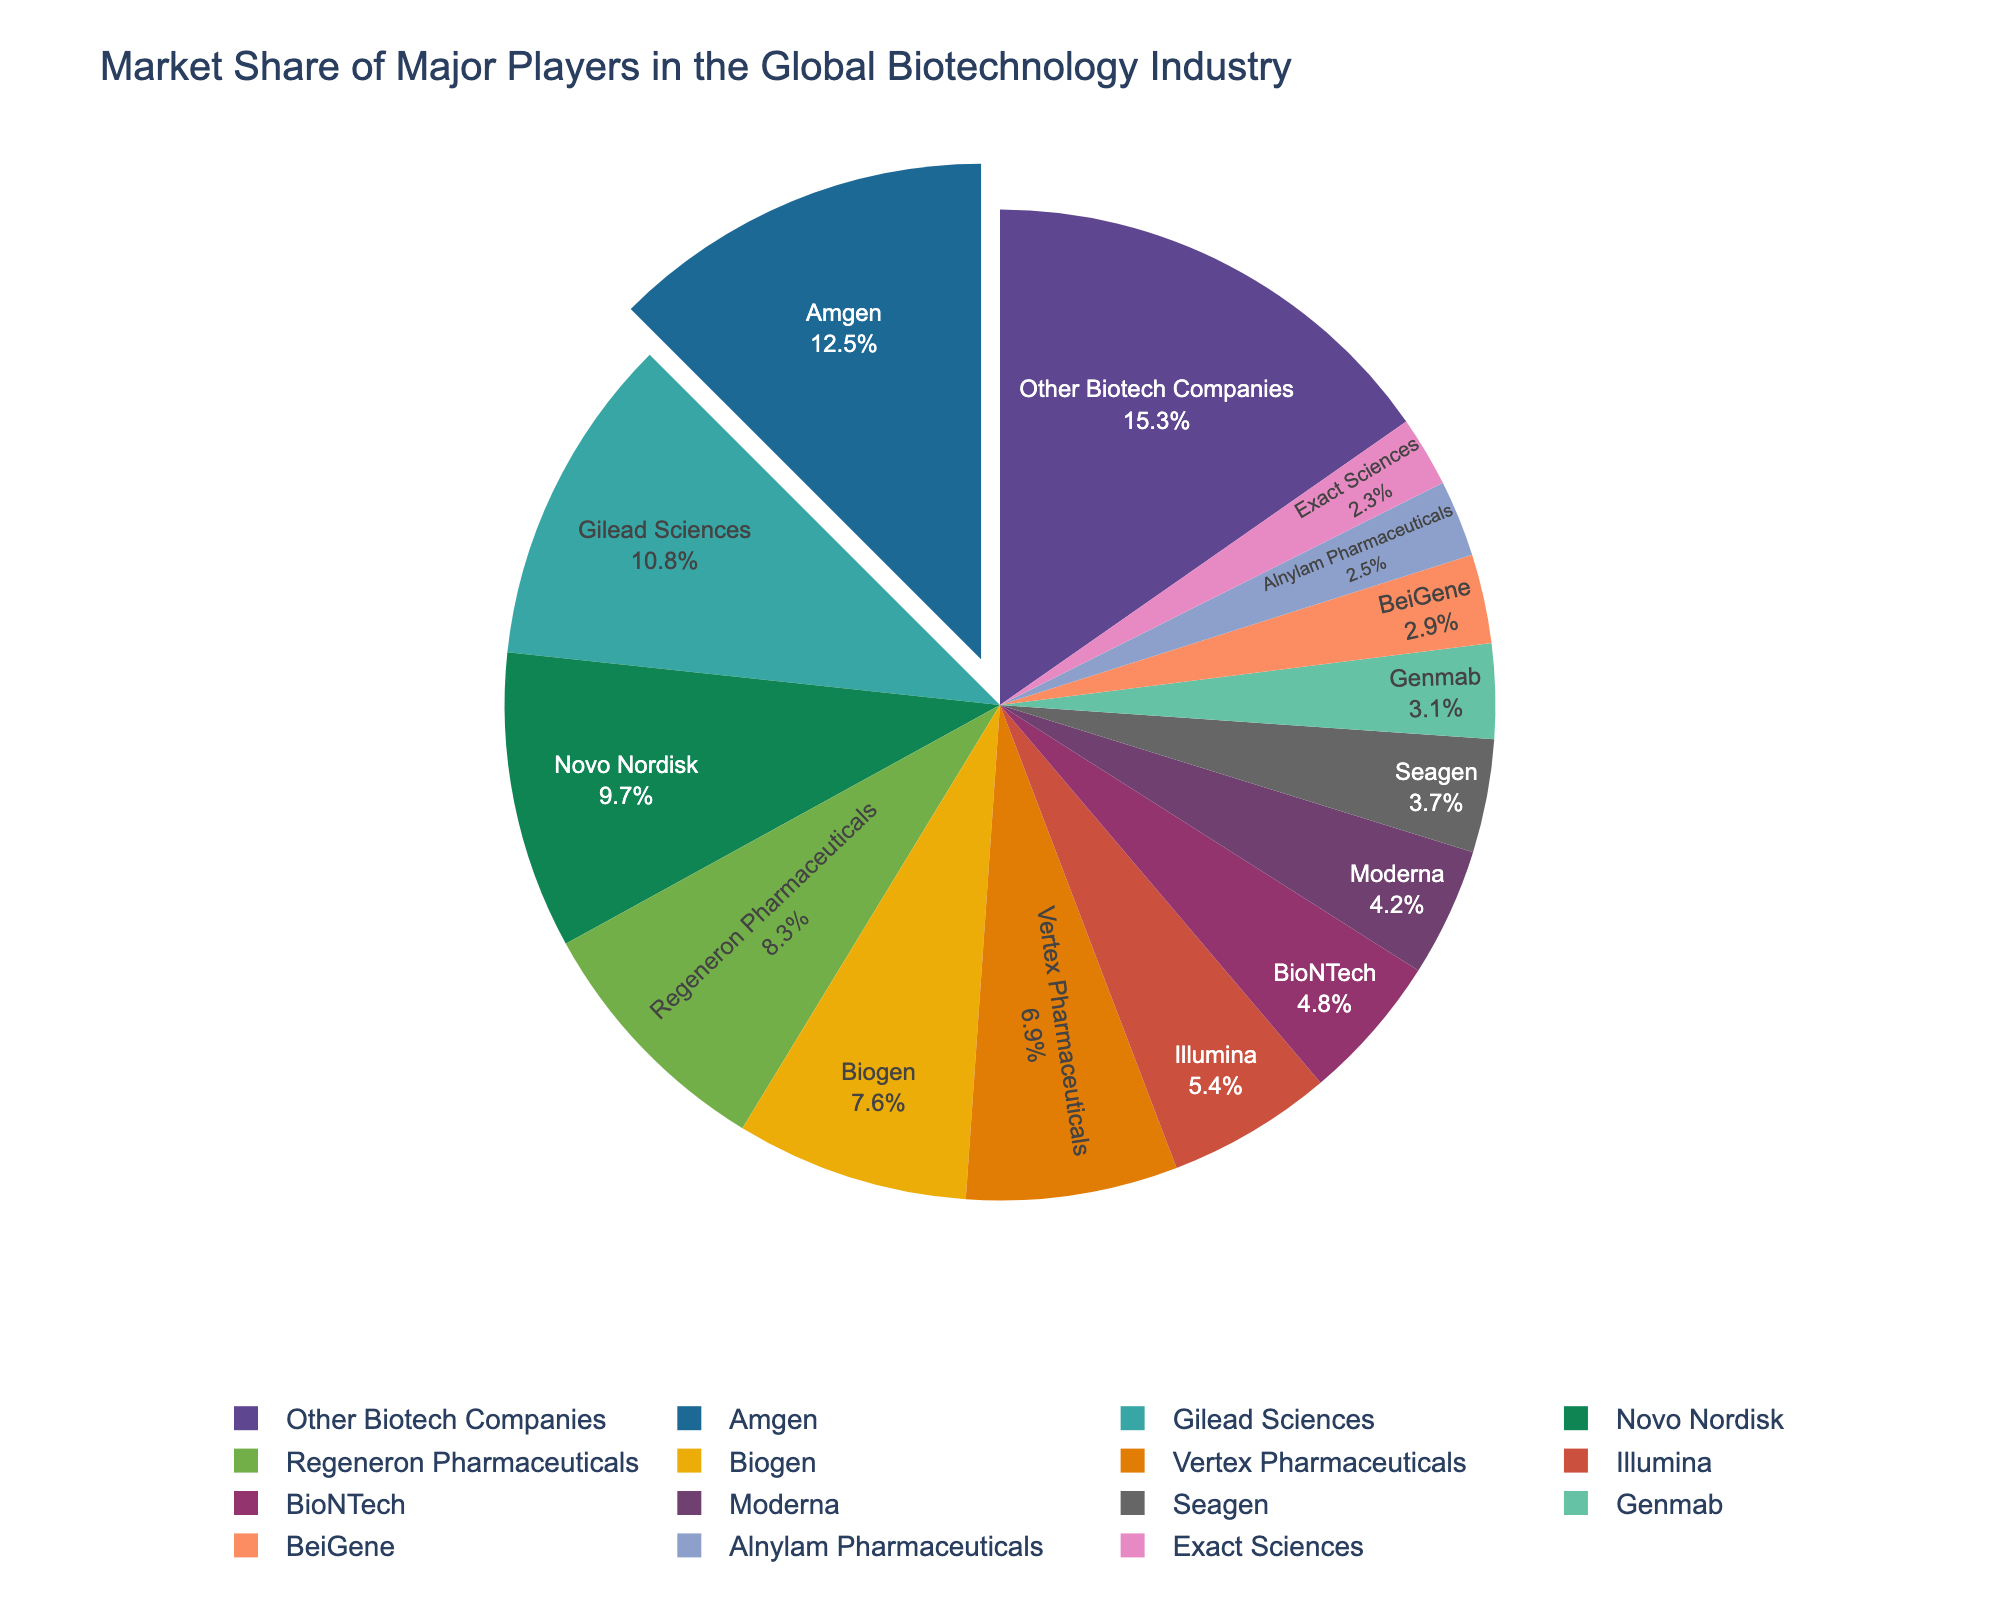What is the market share percentage of the company with the highest market share? To find the company with the highest market share, look for the largest segment in the pie chart. The label inside this segment will show the percentage.
Answer: 12.5% Which company has a higher market share, Biogen or Regeneron Pharmaceuticals? And by how much? First, identify the segments for Biogen and Regeneron Pharmaceuticals. Then, note their respective market shares and subtract the smaller percentage from the larger one. Biogen has 7.6% and Regeneron Pharmaceuticals has 8.3%.
Answer: Regeneron Pharmaceuticals by 0.7% What is the combined market share of BioNTech, Moderna, and Seagen? Identify and sum the market shares of BioNTech (4.8%), Moderna (4.2%), and Seagen (3.7%) from the pie chart. 4.8 + 4.2 + 3.7 = 12.7%.
Answer: 12.7% How does the market share of Amgen compare to that of Gilead Sciences? Identify the market share percentages of Amgen (12.5%) and Gilead Sciences (10.8%) from the pie chart. Compare the two values to see which is larger.
Answer: Amgen has a higher market share than Gilead Sciences What is the market share difference between the smallest segment and the largest segment? Find the smallest segment (Exact Sciences, 2.3%) and the largest segment (Amgen, 12.5%) in the pie chart. Subtract the smallest percentage from the largest (12.5% - 2.3% = 10.2%).
Answer: 10.2% What percentage of the market do companies other than the listed major players account for? Look at the segment labeled "Other Biotech Companies" and note the percentage.
Answer: 15.3% Which company has the nearest market share to 5%? Identify the companies with market shares around 5%. Illumina has a market share of 5.4%, which is closest to 5%.
Answer: Illumina What is the average market share of the top 5 companies? Identify the top 5 companies by their market shares: Amgen (12.5%), Gilead Sciences (10.8%), Novo Nordisk (9.7%), Regeneron Pharmaceuticals (8.3%), and Biogen (7.6%). Sum the market shares and divide by 5. (12.5 + 10.8 + 9.7 + 8.3 + 7.6) / 5 = 9.78%.
Answer: 9.78% How many companies have a market share greater than 10%? Count the segments with market shares greater than 10% from the pie chart. Amgen (12.5%) and Gilead Sciences (10.8%) make 2 companies.
Answer: 2 What is the total market share of all companies listed in the pie chart? Sum all the market share percentages provided in the pie chart, which should total 100%. Verify this by adding each segment's percentage.
Answer: 100% 